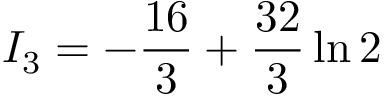Convert formula to latex. <formula><loc_0><loc_0><loc_500><loc_500>I _ { 3 } = - { \frac { 1 6 } { 3 } } + { \frac { 3 2 } { 3 } } \ln 2</formula> 